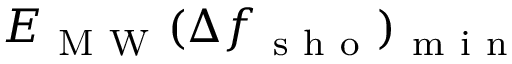<formula> <loc_0><loc_0><loc_500><loc_500>E _ { M W } { ( } \Delta f _ { s h o } { ) } _ { m i n }</formula> 